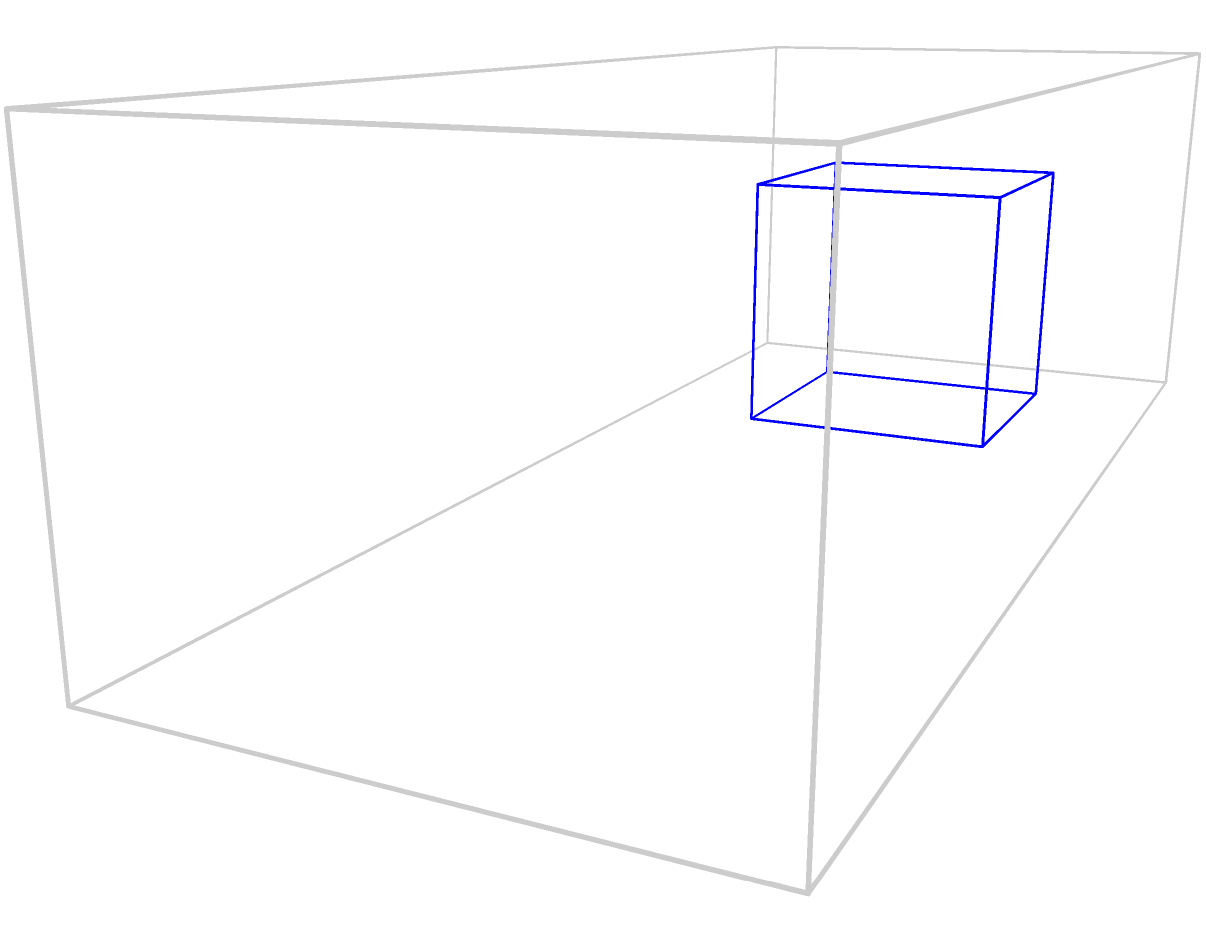You're organizing Christmas gift deliveries and need to maximize space in the truck. The truck's cargo area measures 10 feet long, 4 feet wide, and 3 feet high. You have three types of gift boxes: cubes with 2-foot sides, cylinders with a 2-foot height and 2-foot diameter, and spheres with a 2-foot diameter. If you can stack the boxes, which shape would allow you to fit the most gifts in the truck, and approximately how many could you fit? Let's calculate the volume each shape occupies and how many can fit in the truck:

1. Cube:
   - Volume: $V_c = 2 \times 2 \times 2 = 8$ cubic feet
   - Truck capacity: $10 \times 4 \times 3 = 120$ cubic feet
   - Number of cubes: $\lfloor 120 / 8 \rfloor = 15$ cubes

2. Cylinder:
   - Volume: $V_{cyl} = \pi r^2 h = \pi \times 1^2 \times 2 \approx 6.28$ cubic feet
   - Number of cylinders: $\lfloor 120 / 6.28 \rfloor = 19$ cylinders

3. Sphere:
   - Volume: $V_s = \frac{4}{3}\pi r^3 = \frac{4}{3}\pi \times 1^3 \approx 4.19$ cubic feet
   - Number of spheres: $\lfloor 120 / 4.19 \rfloor = 28$ spheres

However, spheres and cylinders don't stack efficiently, leaving gaps. Cubes stack perfectly with no wasted space.

Actual fit considering stacking:
- Cubes: 5 length × 2 width × 1 height = 10 cubes
- Cylinders: ~4 length × 2 width × 1 height = ~8 cylinders
- Spheres: ~5 length × 2 width × 1 height = ~10 spheres

Therefore, cubes are the most efficient for maximizing space usage in the truck.
Answer: Cubic boxes; 10 boxes 